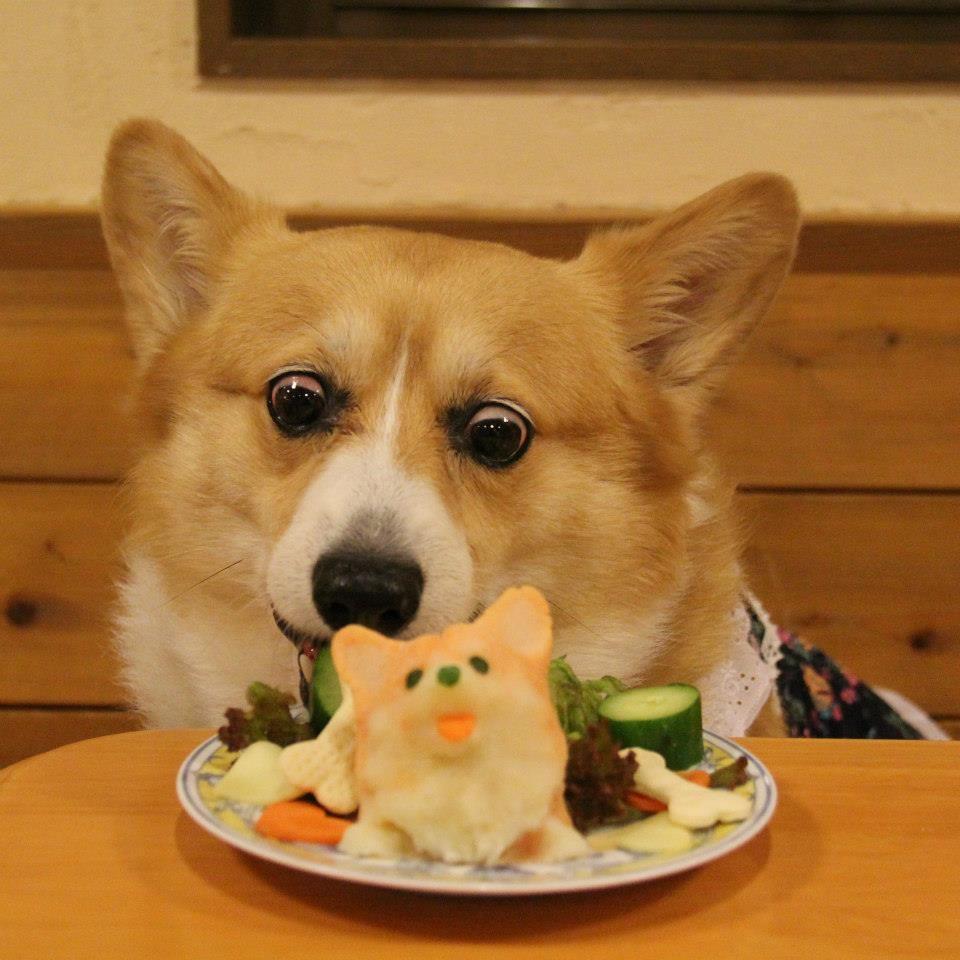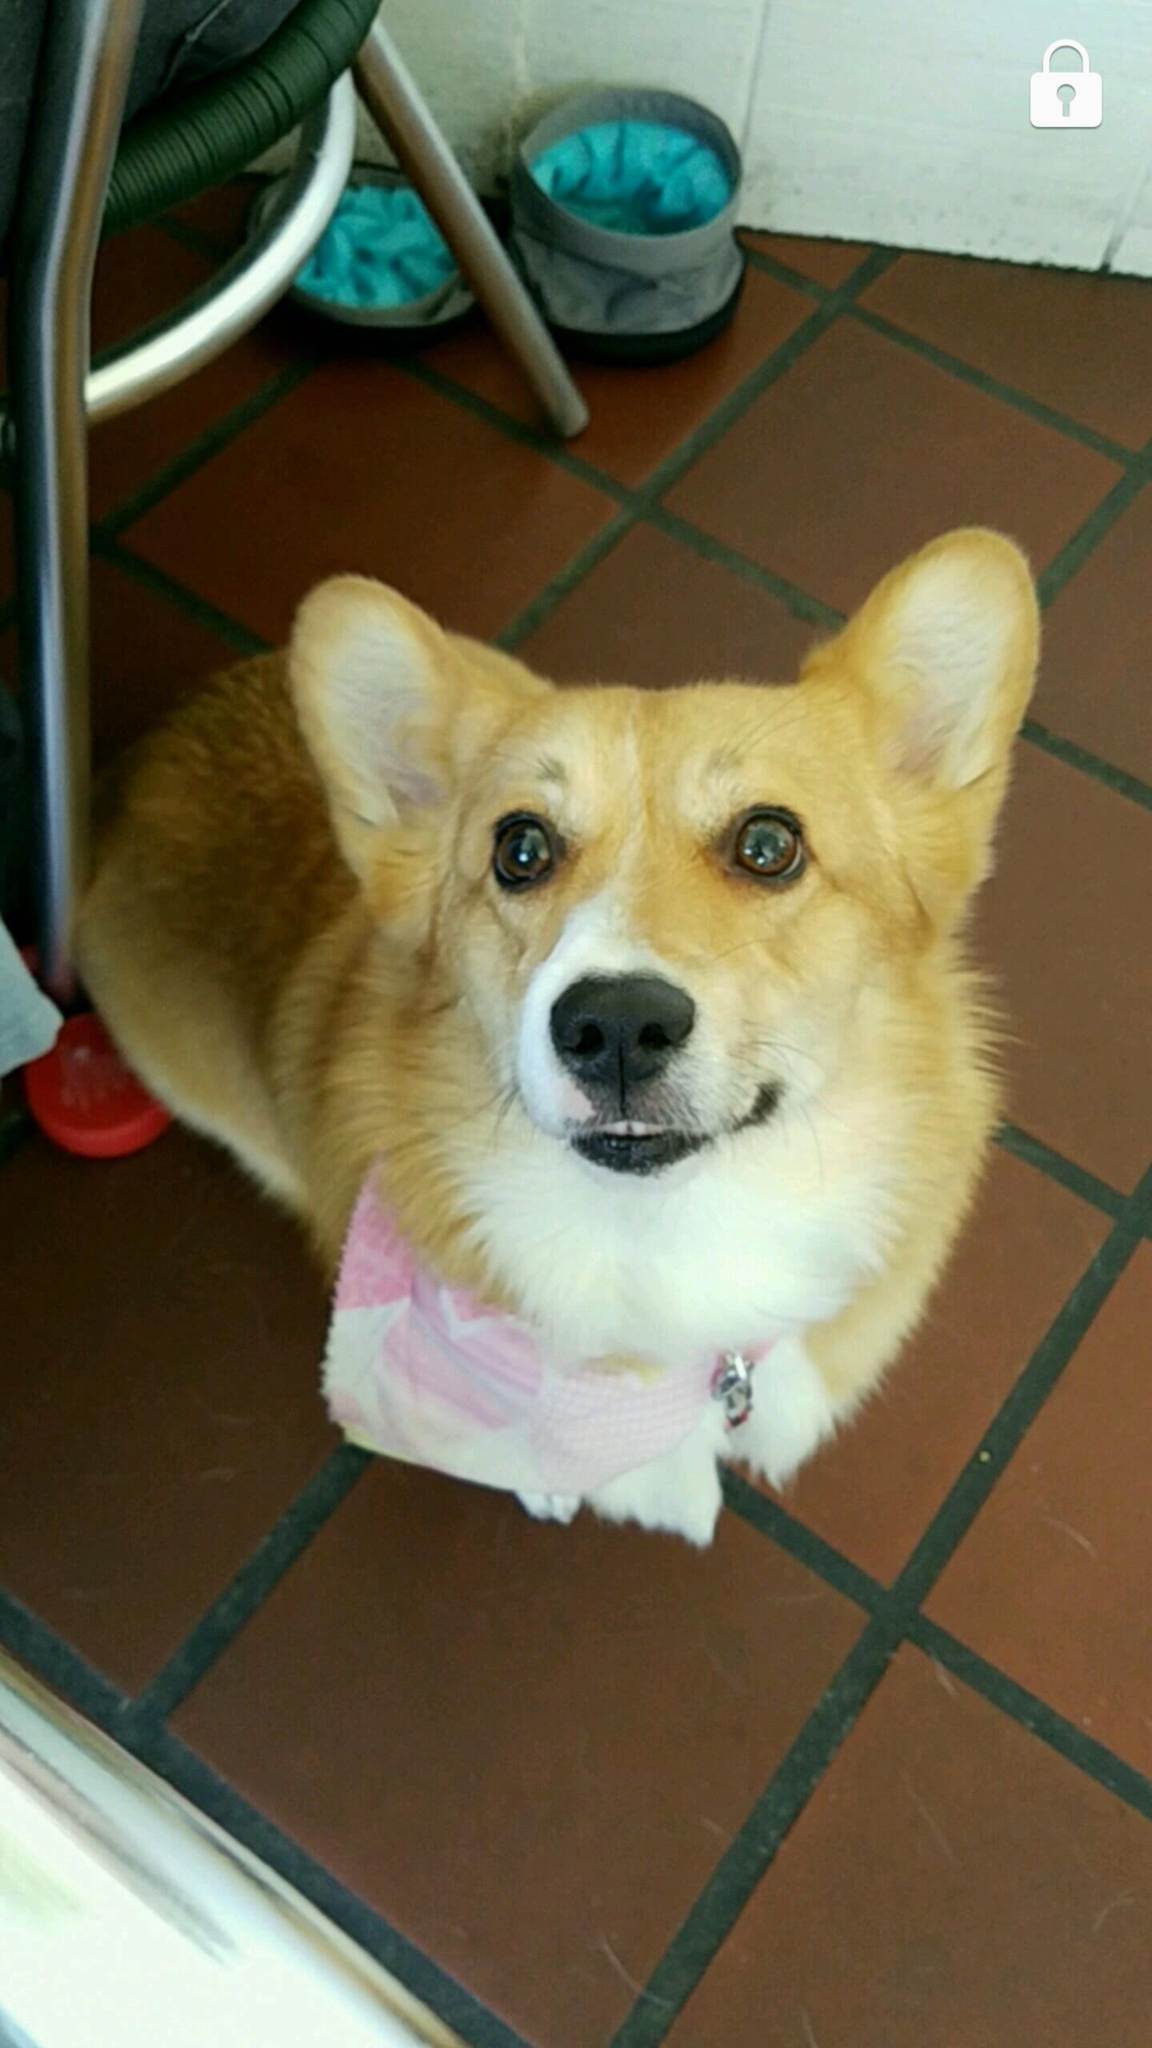The first image is the image on the left, the second image is the image on the right. For the images displayed, is the sentence "There us food in front of a single dog in at least one of the images." factually correct? Answer yes or no. Yes. 